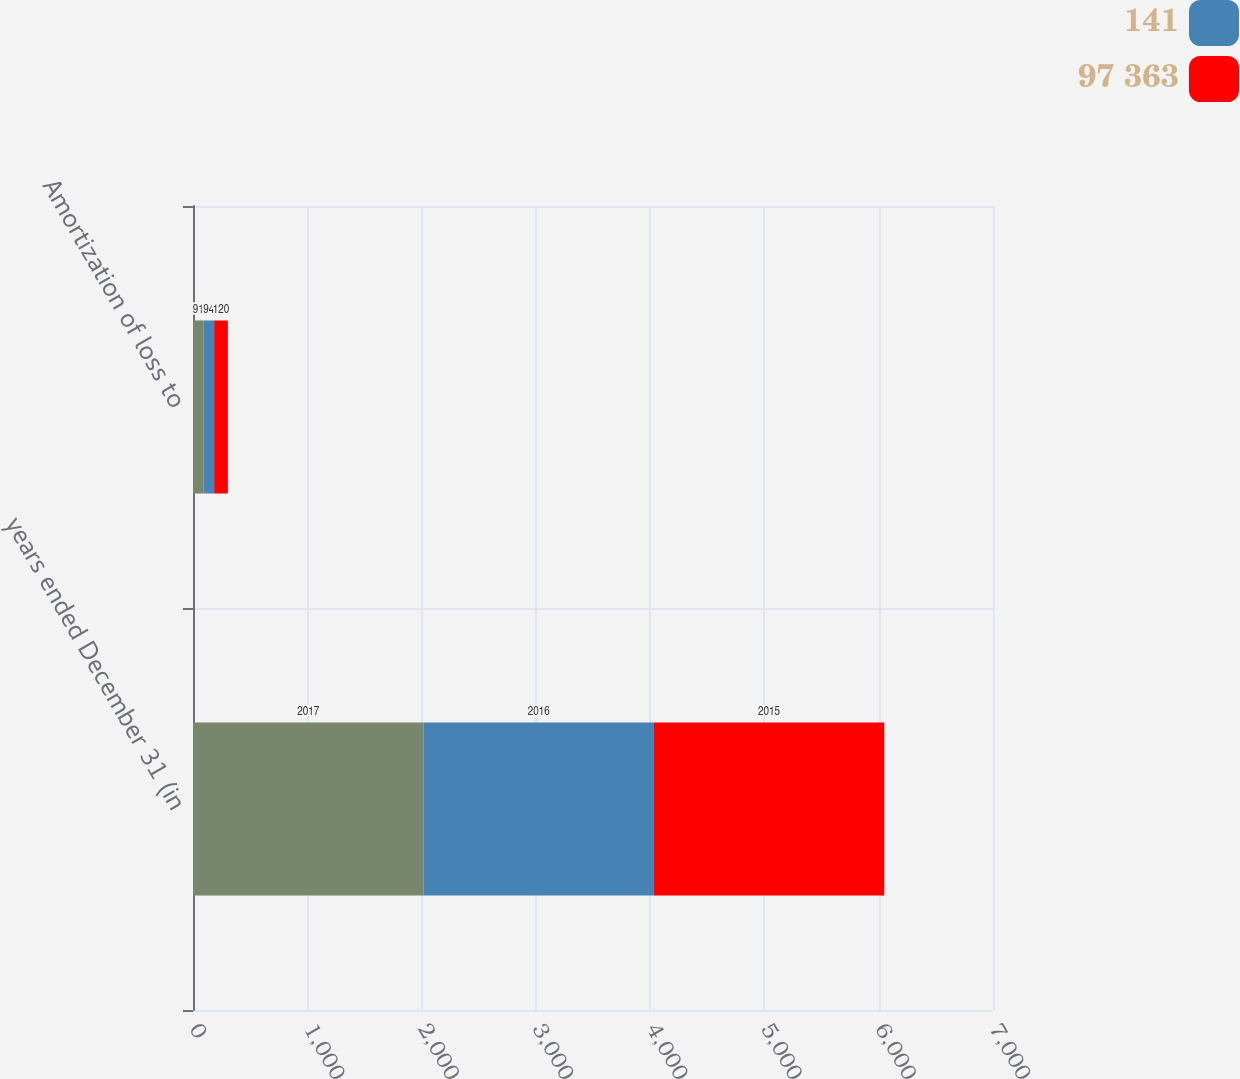Convert chart. <chart><loc_0><loc_0><loc_500><loc_500><stacked_bar_chart><ecel><fcel>years ended December 31 (in<fcel>Amortization of loss to<nl><fcel>nan<fcel>2017<fcel>91<nl><fcel>141<fcel>2016<fcel>94<nl><fcel>97 363<fcel>2015<fcel>120<nl></chart> 